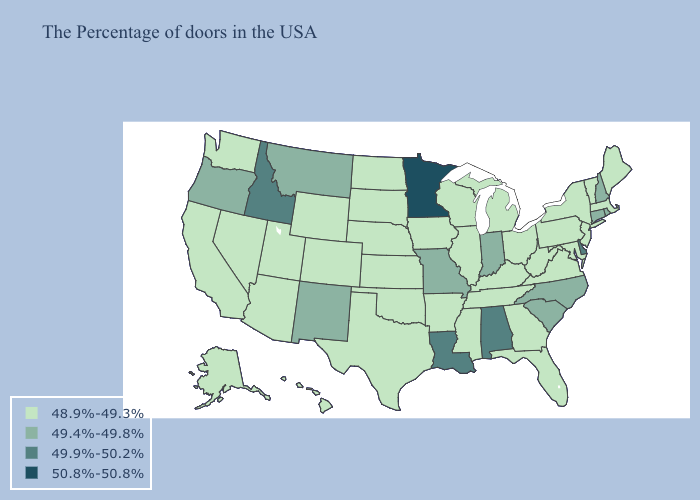Among the states that border Illinois , does Indiana have the lowest value?
Write a very short answer. No. Does Idaho have the highest value in the West?
Write a very short answer. Yes. Does Mississippi have the same value as Minnesota?
Quick response, please. No. What is the value of Maine?
Write a very short answer. 48.9%-49.3%. What is the lowest value in the USA?
Write a very short answer. 48.9%-49.3%. Name the states that have a value in the range 50.8%-50.8%?
Give a very brief answer. Minnesota. Name the states that have a value in the range 49.9%-50.2%?
Keep it brief. Delaware, Alabama, Louisiana, Idaho. What is the value of Massachusetts?
Answer briefly. 48.9%-49.3%. Name the states that have a value in the range 48.9%-49.3%?
Be succinct. Maine, Massachusetts, Vermont, New York, New Jersey, Maryland, Pennsylvania, Virginia, West Virginia, Ohio, Florida, Georgia, Michigan, Kentucky, Tennessee, Wisconsin, Illinois, Mississippi, Arkansas, Iowa, Kansas, Nebraska, Oklahoma, Texas, South Dakota, North Dakota, Wyoming, Colorado, Utah, Arizona, Nevada, California, Washington, Alaska, Hawaii. Name the states that have a value in the range 49.4%-49.8%?
Keep it brief. Rhode Island, New Hampshire, Connecticut, North Carolina, South Carolina, Indiana, Missouri, New Mexico, Montana, Oregon. What is the value of Wisconsin?
Write a very short answer. 48.9%-49.3%. What is the value of Kentucky?
Answer briefly. 48.9%-49.3%. What is the value of Oregon?
Keep it brief. 49.4%-49.8%. 